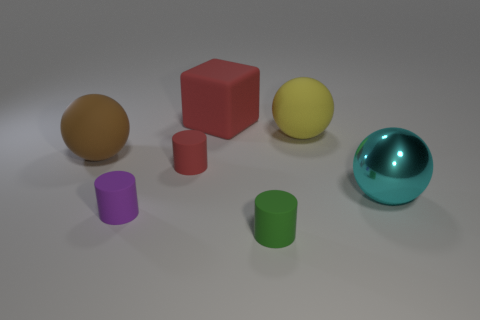Subtract all large rubber balls. How many balls are left? 1 Subtract all balls. How many objects are left? 4 Add 2 small red rubber blocks. How many objects exist? 9 Subtract all large brown matte blocks. Subtract all tiny red things. How many objects are left? 6 Add 1 rubber cylinders. How many rubber cylinders are left? 4 Add 7 gray cubes. How many gray cubes exist? 7 Subtract all purple cylinders. How many cylinders are left? 2 Subtract 0 blue spheres. How many objects are left? 7 Subtract 1 cylinders. How many cylinders are left? 2 Subtract all gray cylinders. Subtract all green balls. How many cylinders are left? 3 